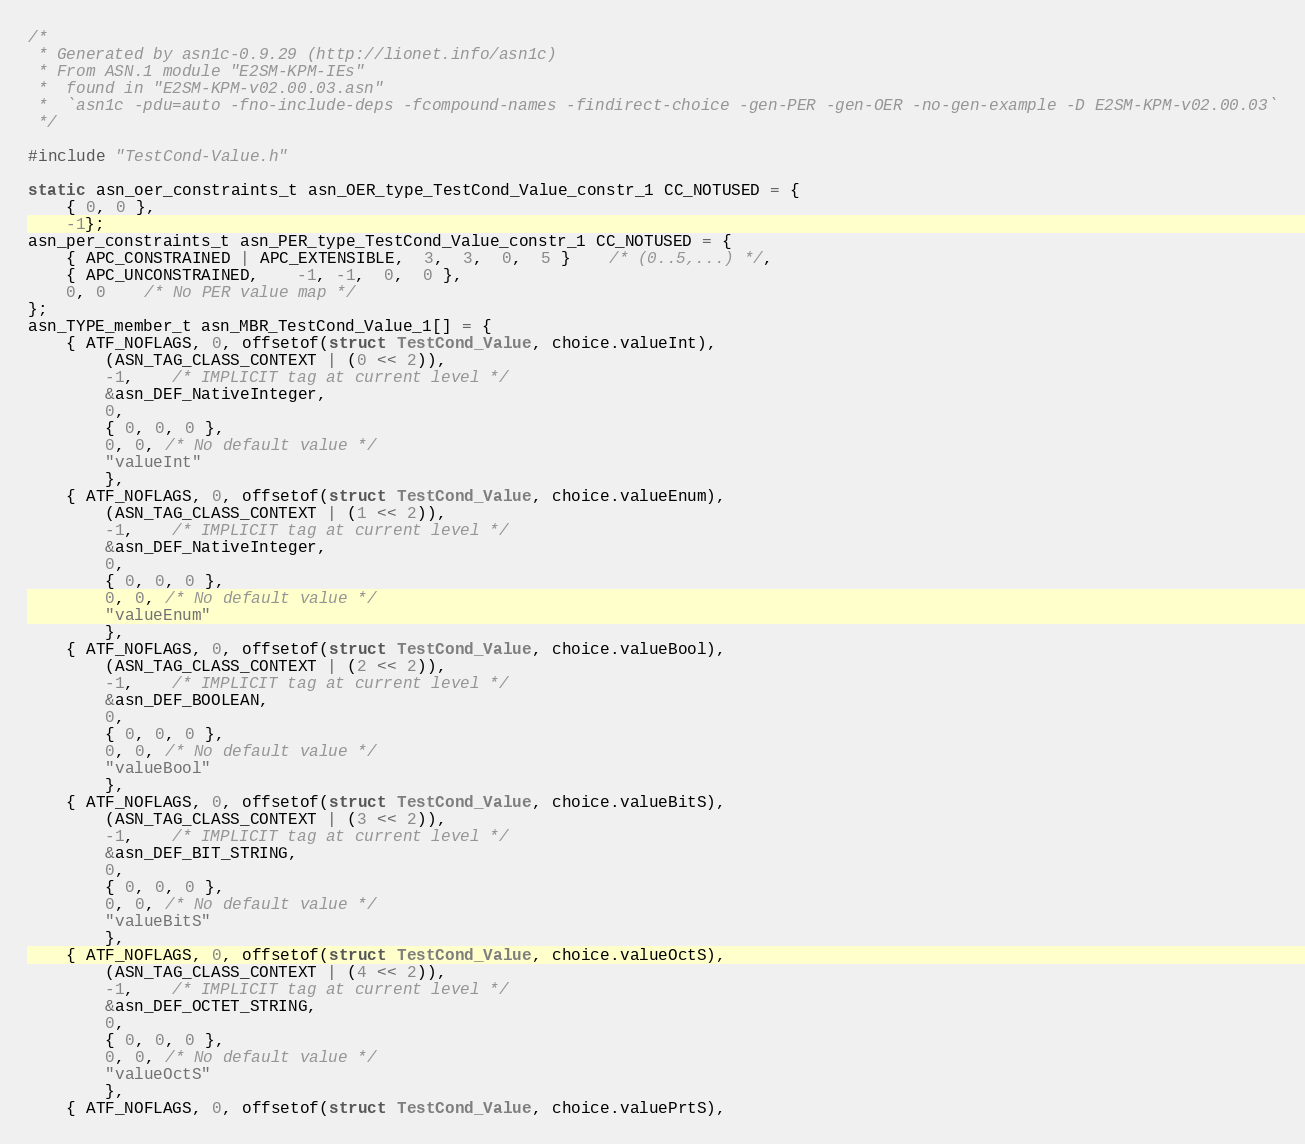Convert code to text. <code><loc_0><loc_0><loc_500><loc_500><_C_>/*
 * Generated by asn1c-0.9.29 (http://lionet.info/asn1c)
 * From ASN.1 module "E2SM-KPM-IEs"
 * 	found in "E2SM-KPM-v02.00.03.asn"
 * 	`asn1c -pdu=auto -fno-include-deps -fcompound-names -findirect-choice -gen-PER -gen-OER -no-gen-example -D E2SM-KPM-v02.00.03`
 */

#include "TestCond-Value.h"

static asn_oer_constraints_t asn_OER_type_TestCond_Value_constr_1 CC_NOTUSED = {
	{ 0, 0 },
	-1};
asn_per_constraints_t asn_PER_type_TestCond_Value_constr_1 CC_NOTUSED = {
	{ APC_CONSTRAINED | APC_EXTENSIBLE,  3,  3,  0,  5 }	/* (0..5,...) */,
	{ APC_UNCONSTRAINED,	-1, -1,  0,  0 },
	0, 0	/* No PER value map */
};
asn_TYPE_member_t asn_MBR_TestCond_Value_1[] = {
	{ ATF_NOFLAGS, 0, offsetof(struct TestCond_Value, choice.valueInt),
		(ASN_TAG_CLASS_CONTEXT | (0 << 2)),
		-1,	/* IMPLICIT tag at current level */
		&asn_DEF_NativeInteger,
		0,
		{ 0, 0, 0 },
		0, 0, /* No default value */
		"valueInt"
		},
	{ ATF_NOFLAGS, 0, offsetof(struct TestCond_Value, choice.valueEnum),
		(ASN_TAG_CLASS_CONTEXT | (1 << 2)),
		-1,	/* IMPLICIT tag at current level */
		&asn_DEF_NativeInteger,
		0,
		{ 0, 0, 0 },
		0, 0, /* No default value */
		"valueEnum"
		},
	{ ATF_NOFLAGS, 0, offsetof(struct TestCond_Value, choice.valueBool),
		(ASN_TAG_CLASS_CONTEXT | (2 << 2)),
		-1,	/* IMPLICIT tag at current level */
		&asn_DEF_BOOLEAN,
		0,
		{ 0, 0, 0 },
		0, 0, /* No default value */
		"valueBool"
		},
	{ ATF_NOFLAGS, 0, offsetof(struct TestCond_Value, choice.valueBitS),
		(ASN_TAG_CLASS_CONTEXT | (3 << 2)),
		-1,	/* IMPLICIT tag at current level */
		&asn_DEF_BIT_STRING,
		0,
		{ 0, 0, 0 },
		0, 0, /* No default value */
		"valueBitS"
		},
	{ ATF_NOFLAGS, 0, offsetof(struct TestCond_Value, choice.valueOctS),
		(ASN_TAG_CLASS_CONTEXT | (4 << 2)),
		-1,	/* IMPLICIT tag at current level */
		&asn_DEF_OCTET_STRING,
		0,
		{ 0, 0, 0 },
		0, 0, /* No default value */
		"valueOctS"
		},
	{ ATF_NOFLAGS, 0, offsetof(struct TestCond_Value, choice.valuePrtS),</code> 